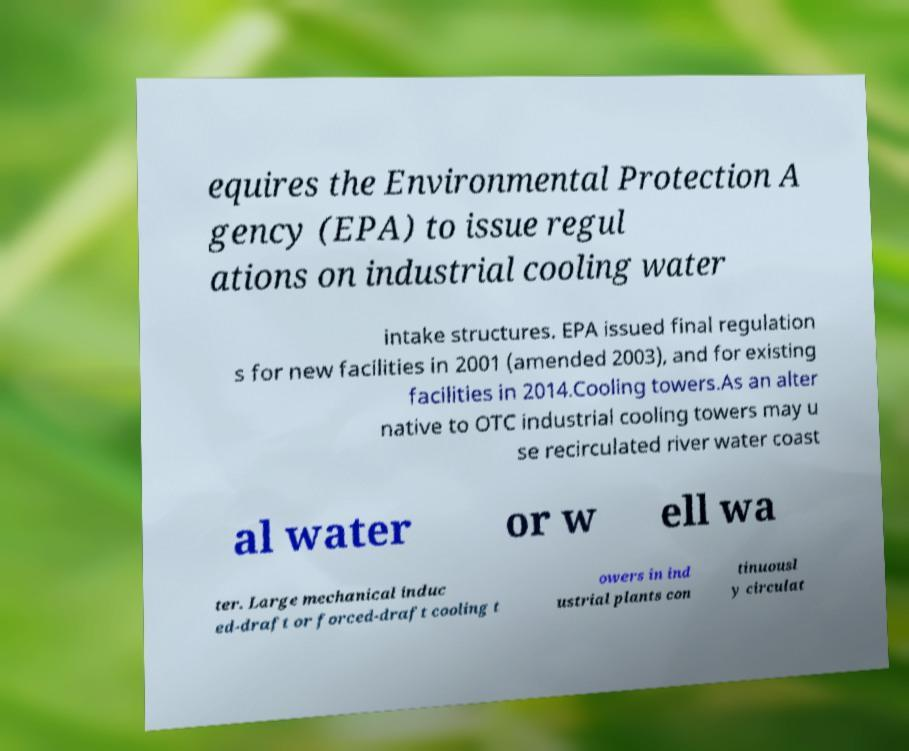Please read and relay the text visible in this image. What does it say? equires the Environmental Protection A gency (EPA) to issue regul ations on industrial cooling water intake structures. EPA issued final regulation s for new facilities in 2001 (amended 2003), and for existing facilities in 2014.Cooling towers.As an alter native to OTC industrial cooling towers may u se recirculated river water coast al water or w ell wa ter. Large mechanical induc ed-draft or forced-draft cooling t owers in ind ustrial plants con tinuousl y circulat 